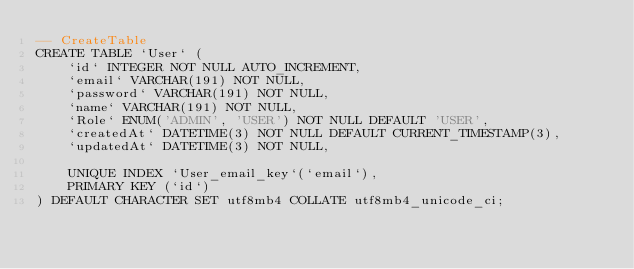Convert code to text. <code><loc_0><loc_0><loc_500><loc_500><_SQL_>-- CreateTable
CREATE TABLE `User` (
    `id` INTEGER NOT NULL AUTO_INCREMENT,
    `email` VARCHAR(191) NOT NULL,
    `password` VARCHAR(191) NOT NULL,
    `name` VARCHAR(191) NOT NULL,
    `Role` ENUM('ADMIN', 'USER') NOT NULL DEFAULT 'USER',
    `createdAt` DATETIME(3) NOT NULL DEFAULT CURRENT_TIMESTAMP(3),
    `updatedAt` DATETIME(3) NOT NULL,

    UNIQUE INDEX `User_email_key`(`email`),
    PRIMARY KEY (`id`)
) DEFAULT CHARACTER SET utf8mb4 COLLATE utf8mb4_unicode_ci;
</code> 